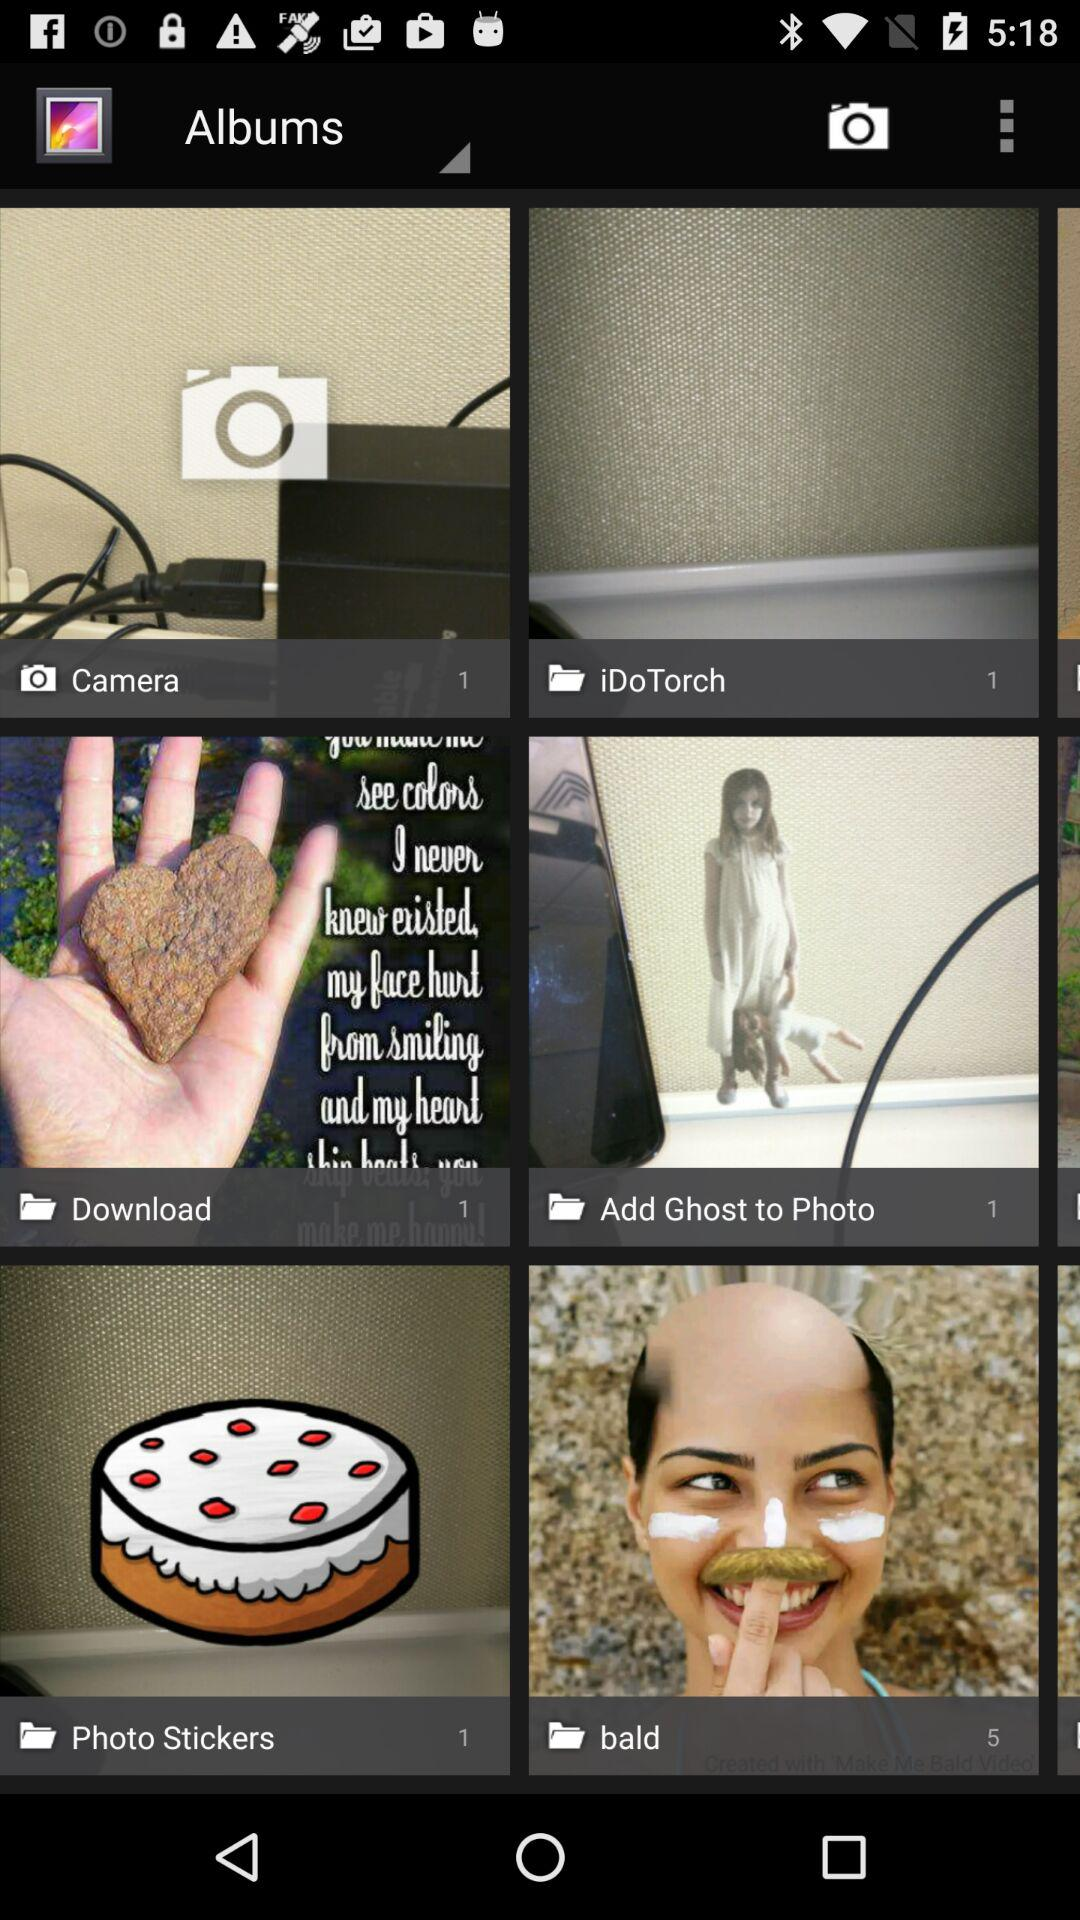How many photos are in the folder named "Download"? There is 1 photo in the folder named "Download". 